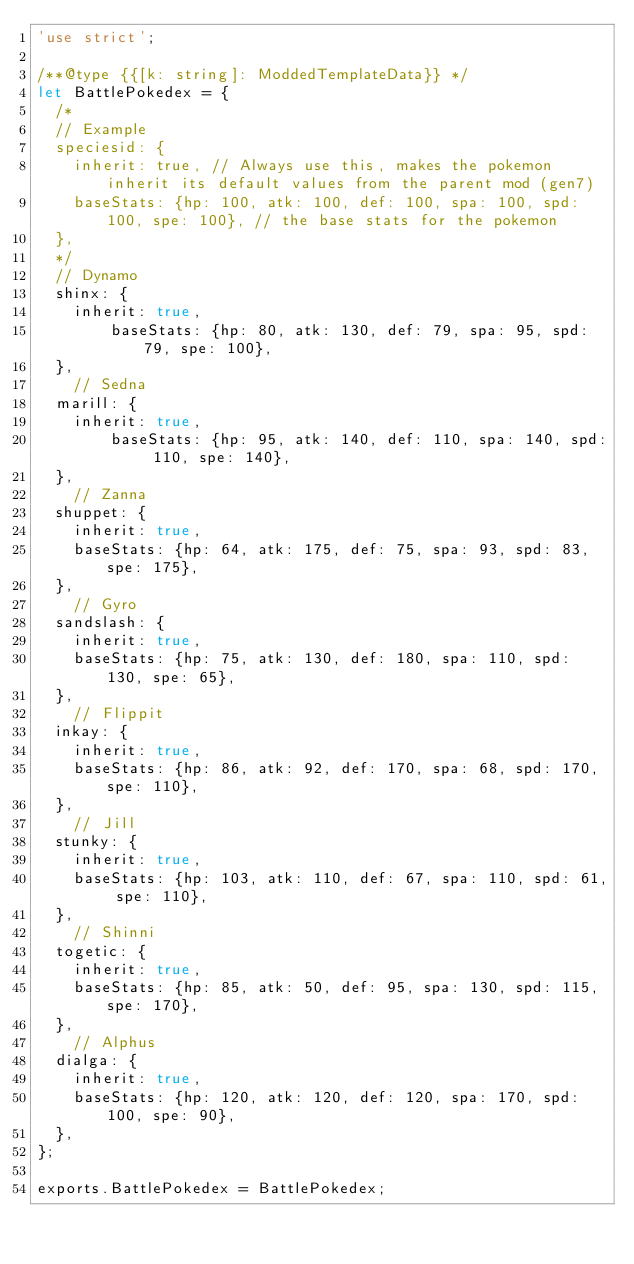Convert code to text. <code><loc_0><loc_0><loc_500><loc_500><_JavaScript_>'use strict';

/**@type {{[k: string]: ModdedTemplateData}} */
let BattlePokedex = {
	/*
	// Example
	speciesid: {
		inherit: true, // Always use this, makes the pokemon inherit its default values from the parent mod (gen7)
		baseStats: {hp: 100, atk: 100, def: 100, spa: 100, spd: 100, spe: 100}, // the base stats for the pokemon
	},
	*/
	// Dynamo
	shinx: {
		inherit: true,
        baseStats: {hp: 80, atk: 130, def: 79, spa: 95, spd: 79, spe: 100},
	},
  	// Sedna
	marill: {
		inherit: true,
        baseStats: {hp: 95, atk: 140, def: 110, spa: 140, spd: 110, spe: 140},
	},
  	// Zanna
	shuppet: {
		inherit: true,
		baseStats: {hp: 64, atk: 175, def: 75, spa: 93, spd: 83, spe: 175},
	},
  	// Gyro
	sandslash: {
		inherit: true,
		baseStats: {hp: 75, atk: 130, def: 180, spa: 110, spd: 130, spe: 65},
	},
  	// Flippit
	inkay: {
		inherit: true,
		baseStats: {hp: 86, atk: 92, def: 170, spa: 68, spd: 170, spe: 110},
	},
  	// Jill
	stunky: {
		inherit: true,
		baseStats: {hp: 103, atk: 110, def: 67, spa: 110, spd: 61, spe: 110},
	},
  	// Shinni
	togetic: {
		inherit: true,
		baseStats: {hp: 85, atk: 50, def: 95, spa: 130, spd: 115, spe: 170},
	},
  	// Alphus
	dialga: {
		inherit: true,
		baseStats: {hp: 120, atk: 120, def: 120, spa: 170, spd: 100, spe: 90},
	},
};

exports.BattlePokedex = BattlePokedex;
</code> 